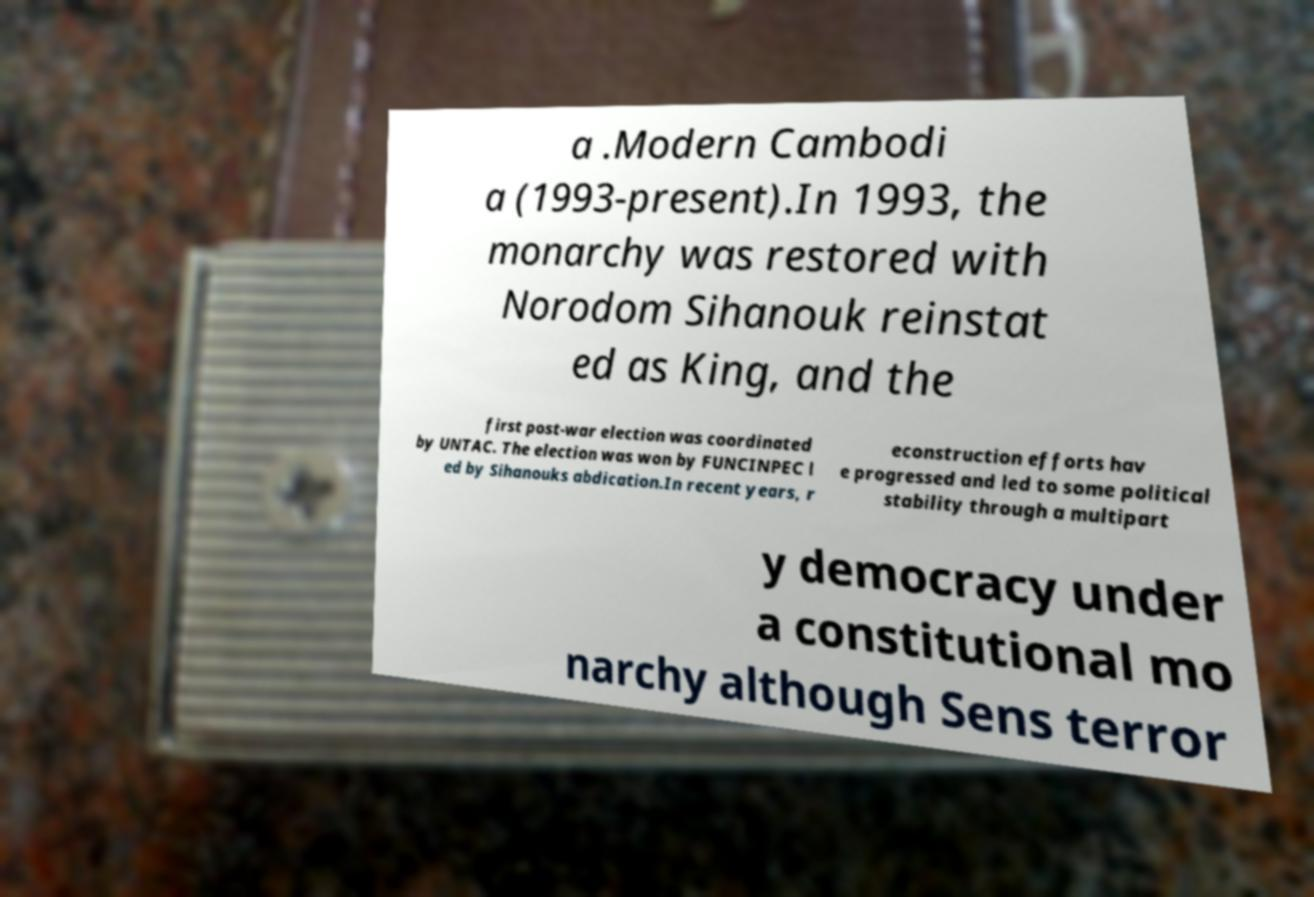I need the written content from this picture converted into text. Can you do that? a .Modern Cambodi a (1993-present).In 1993, the monarchy was restored with Norodom Sihanouk reinstat ed as King, and the first post-war election was coordinated by UNTAC. The election was won by FUNCINPEC l ed by Sihanouks abdication.In recent years, r econstruction efforts hav e progressed and led to some political stability through a multipart y democracy under a constitutional mo narchy although Sens terror 